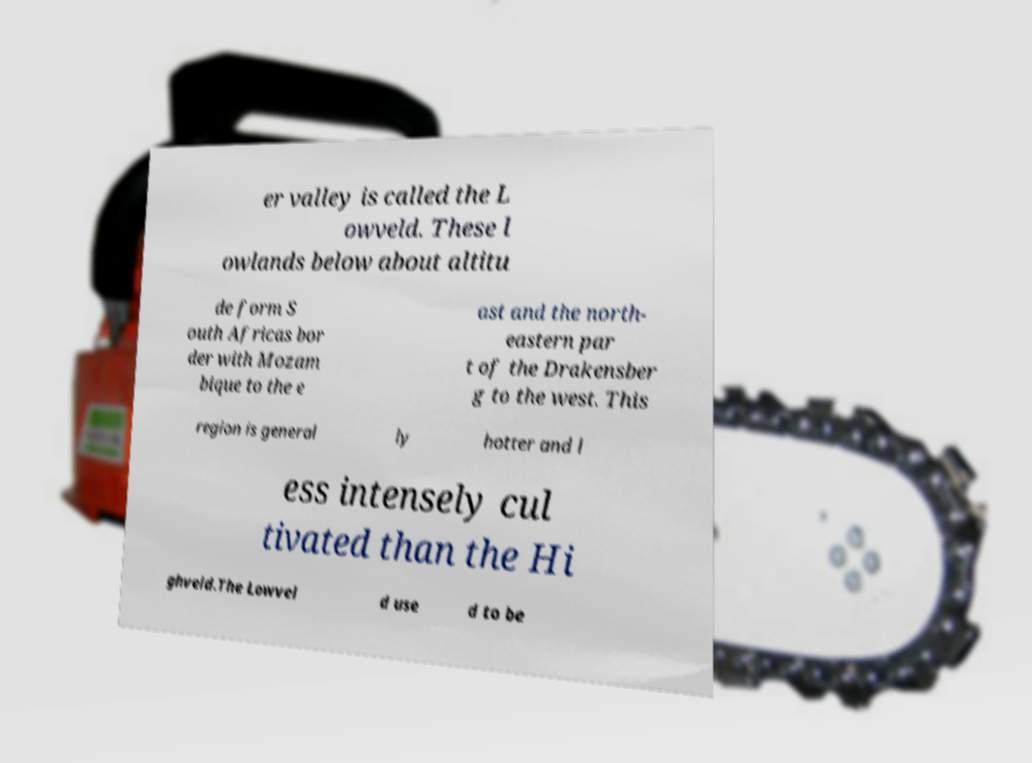Please read and relay the text visible in this image. What does it say? er valley is called the L owveld. These l owlands below about altitu de form S outh Africas bor der with Mozam bique to the e ast and the north- eastern par t of the Drakensber g to the west. This region is general ly hotter and l ess intensely cul tivated than the Hi ghveld.The Lowvel d use d to be 